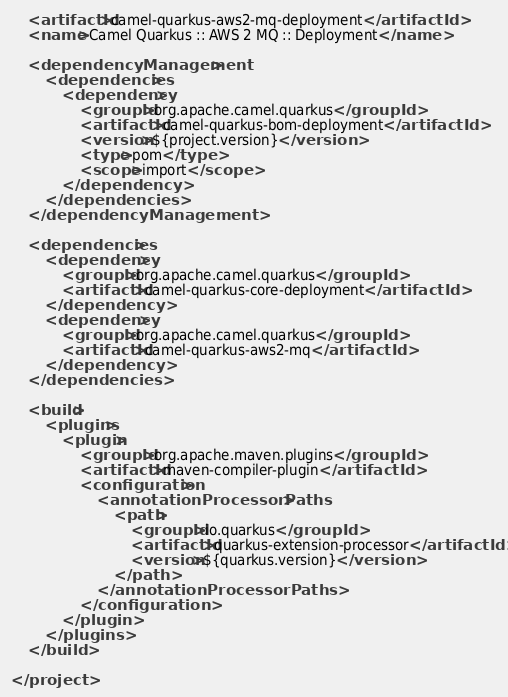Convert code to text. <code><loc_0><loc_0><loc_500><loc_500><_XML_>
    <artifactId>camel-quarkus-aws2-mq-deployment</artifactId>
    <name>Camel Quarkus :: AWS 2 MQ :: Deployment</name>

    <dependencyManagement>
        <dependencies>
            <dependency>
                <groupId>org.apache.camel.quarkus</groupId>
                <artifactId>camel-quarkus-bom-deployment</artifactId>
                <version>${project.version}</version>
                <type>pom</type>
                <scope>import</scope>
            </dependency>
        </dependencies>
    </dependencyManagement>

    <dependencies>
        <dependency>
            <groupId>org.apache.camel.quarkus</groupId>
            <artifactId>camel-quarkus-core-deployment</artifactId>
        </dependency>
        <dependency>
            <groupId>org.apache.camel.quarkus</groupId>
            <artifactId>camel-quarkus-aws2-mq</artifactId>
        </dependency>
    </dependencies>

    <build>
        <plugins>
            <plugin>
                <groupId>org.apache.maven.plugins</groupId>
                <artifactId>maven-compiler-plugin</artifactId>
                <configuration>
                    <annotationProcessorPaths>
                        <path>
                            <groupId>io.quarkus</groupId>
                            <artifactId>quarkus-extension-processor</artifactId>
                            <version>${quarkus.version}</version>
                        </path>
                    </annotationProcessorPaths>
                </configuration>
            </plugin>
        </plugins>
    </build>

</project>
</code> 